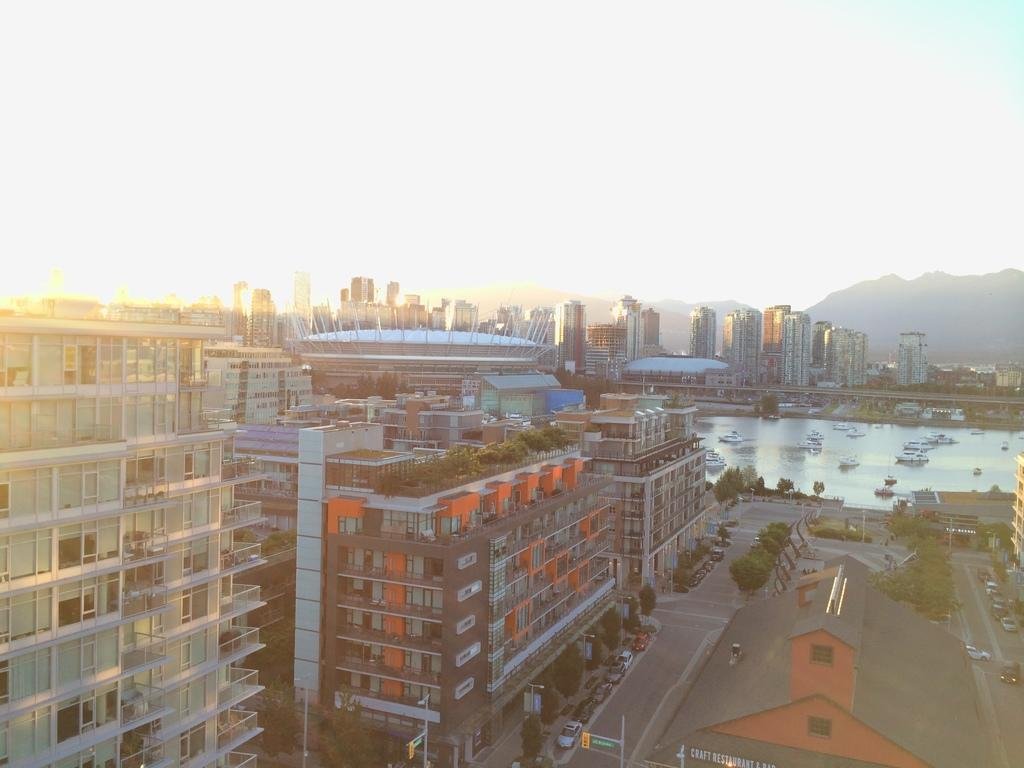What is on the water in the image? There are boats on the water in the image. What types of transportation can be seen in the image? There are vehicles in the image. What natural elements are present in the image? There are trees in the image. What type of architecture is visible in the image? There are buildings with glass windows in the image. What geographical feature can be seen in the distance? There is a mountain visible in the distance. What direction is the prison located in the image? There is no prison present in the image. What type of bread is being baked in the loaf in the image? There is no loaf of bread present in the image. 